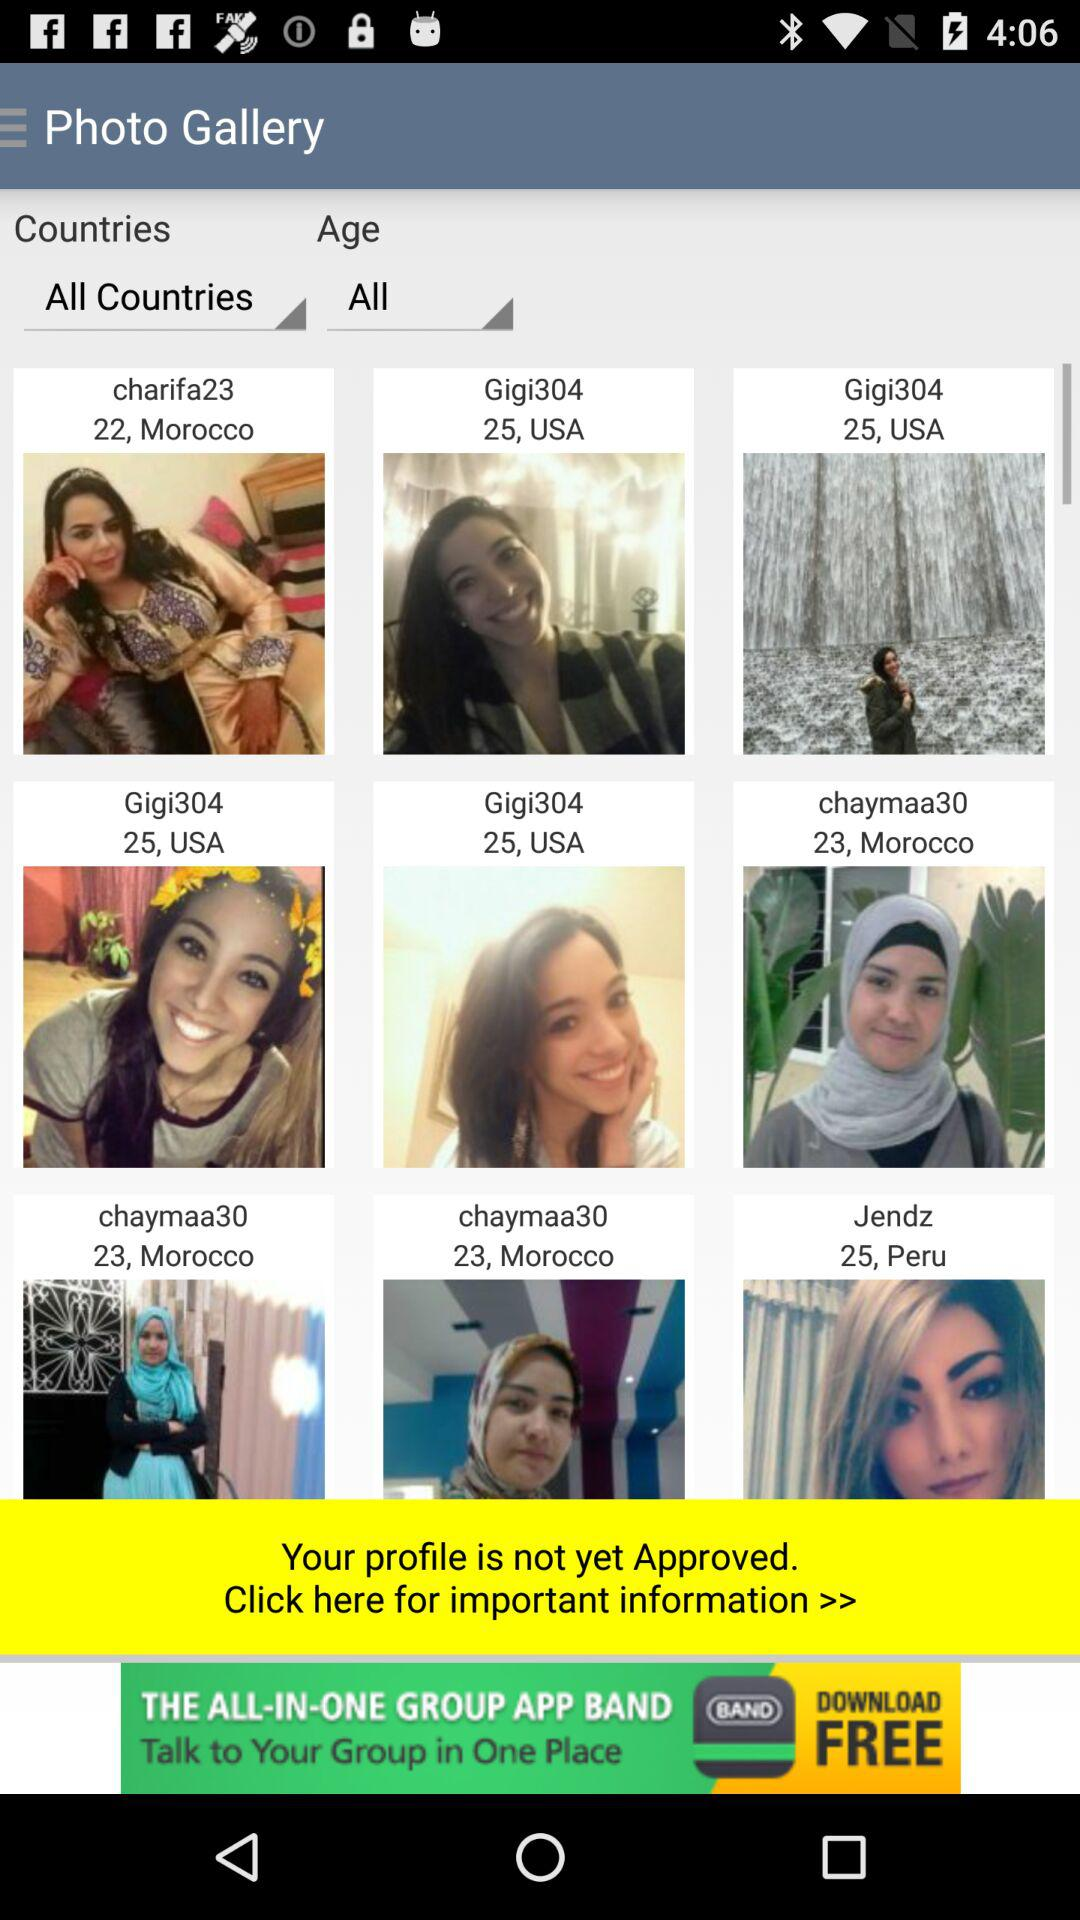Which user lives in Peru? The user who lives in Peru is "Jendz". 